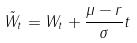<formula> <loc_0><loc_0><loc_500><loc_500>\tilde { W } _ { t } = W _ { t } + \frac { \mu - r } { \sigma } t</formula> 